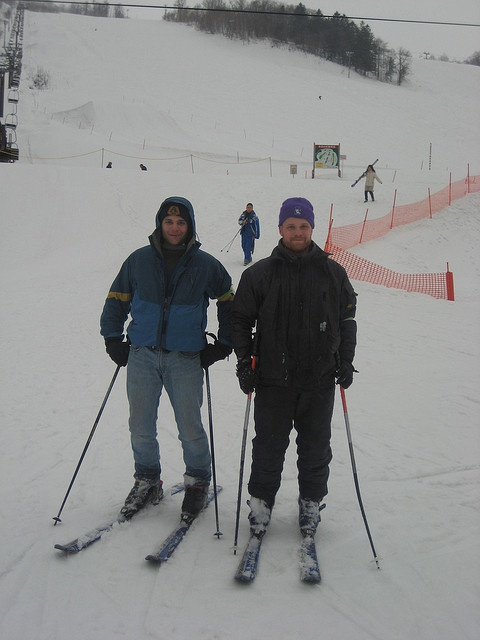Describe the objects in this image and their specific colors. I can see people in gray, black, and darkgray tones, people in gray, black, darkblue, and purple tones, skis in gray and black tones, skis in gray and black tones, and people in gray, navy, black, and darkblue tones in this image. 